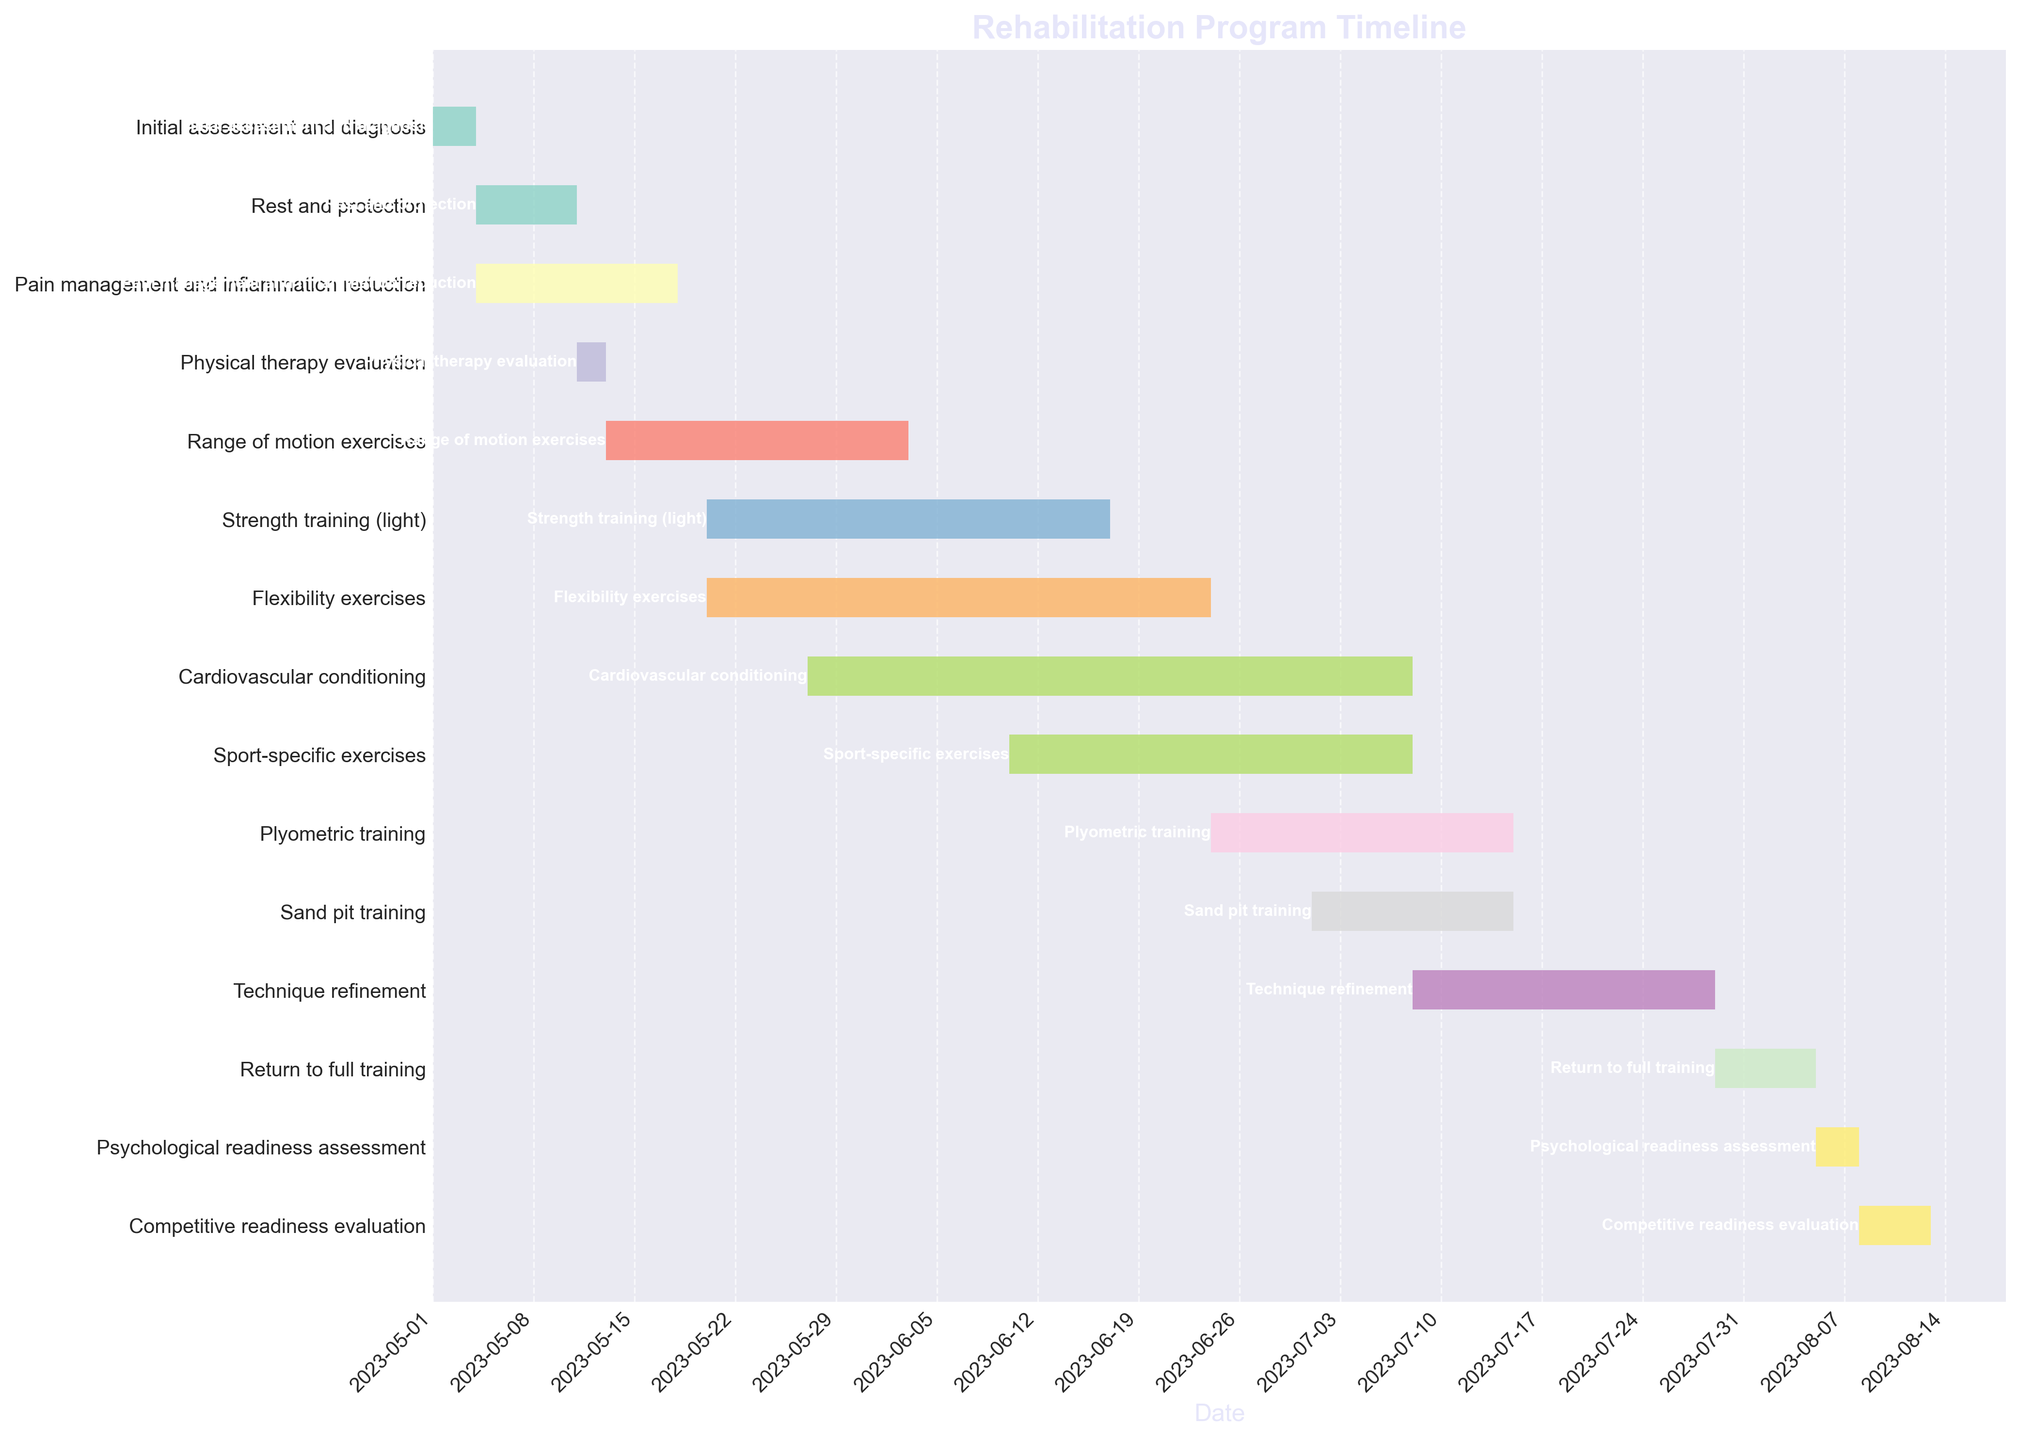What is the total duration of the "Pain management and inflammation reduction" phase? The "Pain management and inflammation reduction" phase starts on 2023-05-04 and lasts for 14 days as indicated in the plot.
Answer: 14 days What is the first stage in the rehabilitation program? The first task listed at the top of the Gantt Chart is "Initial assessment and diagnosis," which starts on 2023-05-01.
Answer: Initial assessment and diagnosis Which task starts on the same date as "Flexibility exercises"? Both "Strength training (light)" and "Flexibility exercises" start on 2023-05-20, as depicted in the Gantt Chart.
Answer: Strength training (light) Which activity has the longest duration? By observing the bar lengths in the Gantt Chart, "Cardiovascular conditioning" has the longest duration, lasting 42 days.
Answer: Cardiovascular conditioning Which phase follows immediately after "Sand pit training"? In the Gantt Chart, "Technique refinement" starts immediately after "Sand pit training" ends on 2023-07-14.
Answer: Technique refinement What is the duration difference between "Sport-specific exercises" and "Plyometric training"? "Sport-specific exercises" last for 28 days, and "Plyometric training" lasts for 21 days. The duration difference is 28 - 21 = 7 days.
Answer: 7 days How many days are allocated between the "Return to full training" and the "Competitive readiness evaluation"? "Return to full training" ends on 2023-08-05, and the "Competitive readiness evaluation" starts on 2023-08-08, making it a gap of 3 days.
Answer: 3 days Which tasks are conducted at the same time as "Range of motion exercises"? "Range of motion exercises" run from 2023-05-13 to 2023-06-03; during this time, "Strength training (light)" and "Flexibility exercises" both overlap with it.
Answer: Strength training (light) and Flexibility exercises What percentage of the program is dedicated to "Cardiovascular conditioning"? The total duration of all phases sums up to 250 days. "Cardiovascular conditioning" lasts for 42 days, so the percentage is (42/250) * 100 = 16.8%.
Answer: 16.8% What are the two shortest tasks in the rehabilitation program? By comparing the bars in the Gantt Chart, the shortest tasks are "Initial assessment and diagnosis" and "Psychological readiness assessment," each lasting for 3 days.
Answer: Initial assessment and diagnosis and Psychological readiness assessment 